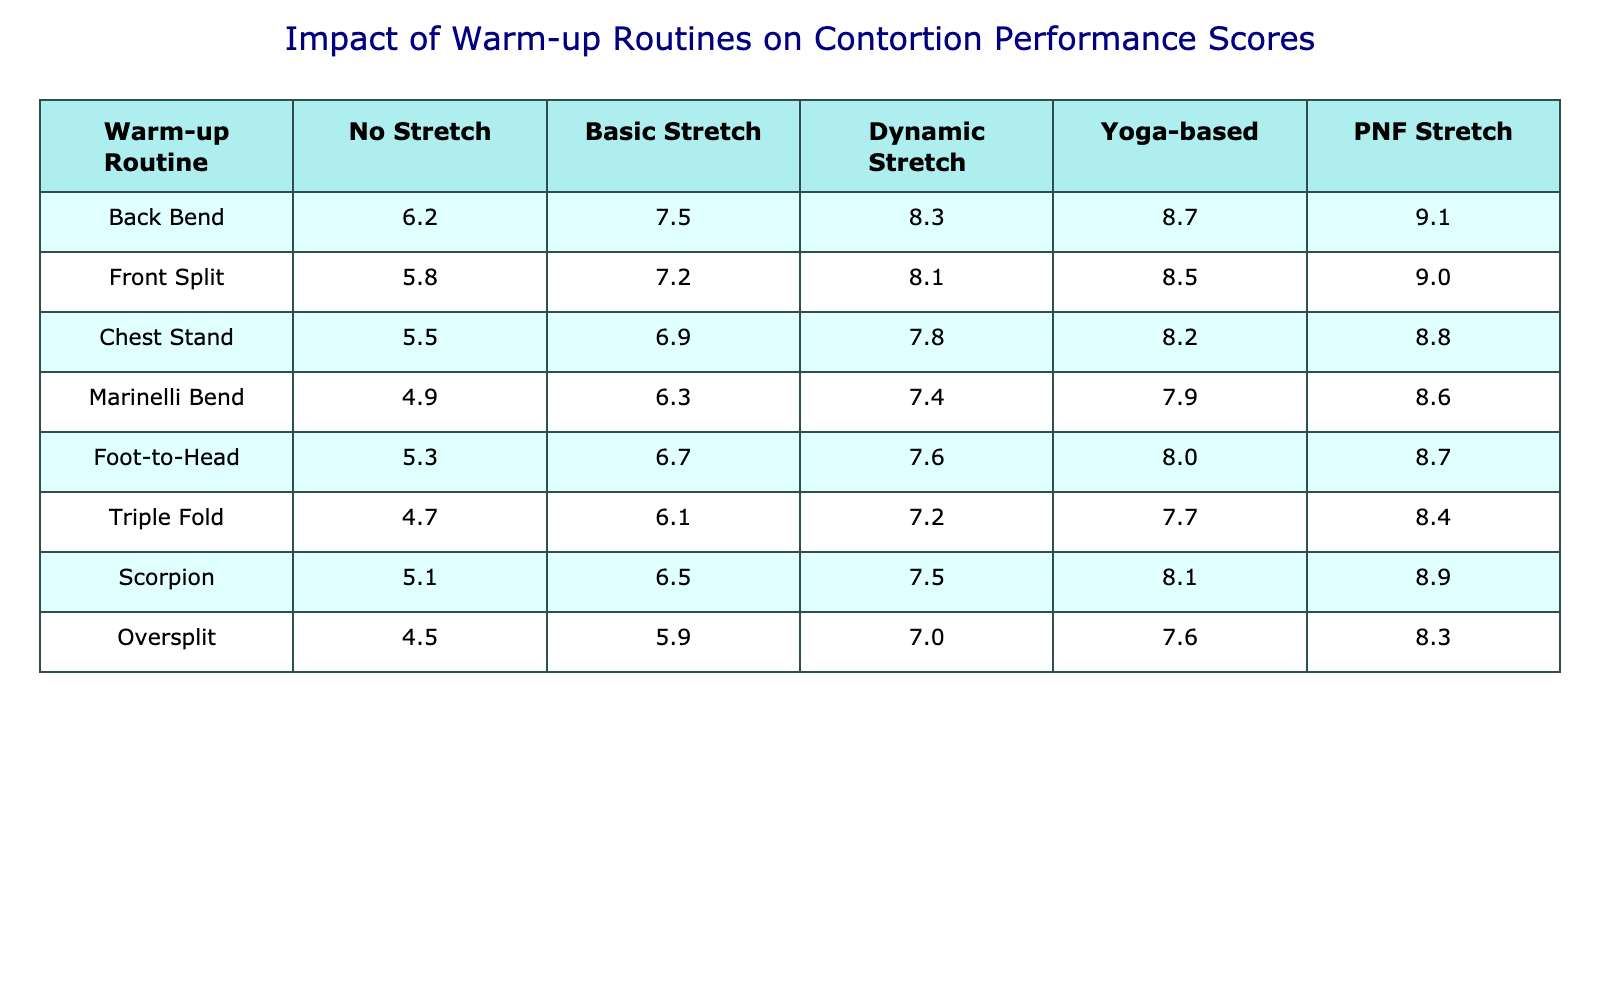What is the highest performance score for the Back Bend routine? Looking at the Back Bend row, the scores are 6.2 for No Stretch, 7.5 for Basic Stretch, 8.3 for Dynamic Stretch, 8.7 for Yoga-based, and 9.1 for PNF Stretch. The highest value among these is 9.1.
Answer: 9.1 What warm-up routine results in the lowest performance score? By scanning all the scores across each warm-up routine row, the lowest score is 4.5 for the Oversplit routine under the No Stretch category.
Answer: 4.5 Which warm-up routine had the highest improvement from No Stretch to PNF Stretch? Comparing the No Stretch and PNF Stretch scores for each warm-up routine, the difference for each is calculated: Back Bend (9.1 - 6.2 = 2.9), Front Split (9.0 - 5.8 = 3.2), Chest Stand (8.8 - 5.5 = 3.3), Marinelli Bend (8.6 - 4.9 = 3.7), Foot-to-Head (8.7 - 5.3 = 3.4), Triple Fold (8.4 - 4.7 = 3.7), Scorpion (8.9 - 5.1 = 3.8), and Oversplit (8.3 - 4.5 = 3.8). The highest improvement is 3.8 for both Scorpion and Oversplit routines.
Answer: Scorpion and Oversplit What is the average performance score across all routines for Basic Stretch? The Basic Stretch scores are 7.5, 7.2, 6.9, 6.3, 6.7, 6.1, 6.5, and 5.9. Adding these gives 48.1, and dividing by 8 (the number of data points) gives an average of 6.0125. After rounding, the average score is approximately 6.0.
Answer: 6.0 Which warm-up routine had the largest score drop from Dynamic Stretch to No Stretch? Calculate the differences for each warm-up routine: Back Bend (6.2 - 8.3 = -2.1), Front Split (5.8 - 8.1 = -2.3), Chest Stand (5.5 - 7.8 = -2.3), Marinelli Bend (4.9 - 7.4 = -2.5), Foot-to-Head (5.3 - 7.6 = -2.3), Triple Fold (4.7 - 7.2 = -2.5), Scorpion (5.1 - 7.5 = -2.4), and Oversplit (4.5 - 7.0 = -2.5). The largest drop is -2.5 for Marinelli Bend, Triple Fold, and Oversplit.
Answer: Marinelli Bend, Triple Fold, and Oversplit Does Yoga-based stretching consistently provide better scores than Basic Stretch across all routines? Comparing the scores for Yoga-based and Basic Stretch for each warm-up routine: Back Bend (8.7 vs 7.5), Front Split (8.5 vs 7.2), Chest Stand (8.2 vs 6.9), Marinelli Bend (7.9 vs 6.3), Foot-to-Head (8.0 vs 6.7), Triple Fold (7.7 vs 6.1), Scorpion (8.1 vs 6.5), and Oversplit (7.6 vs 5.9), Yoga-based stretching is superior in all instances.
Answer: Yes What is the average performance score for all warm-up routines using PNF Stretch? The PNF Stretch scores are 9.1, 9.0, 8.8, 8.6, 8.7, 8.4, 8.9, and 8.3. Summing these gives 70.8, and dividing by 8 gives an average score of 8.85.
Answer: 8.85 How do the scores for Front Split compare between Dynamic Stretch and PNF Stretch? The Front Split scores are 8.1 for Dynamic Stretch and 9.0 for PNF Stretch. Comparing the two, PNF Stretch is higher by 0.9.
Answer: PNF Stretch is higher by 0.9 